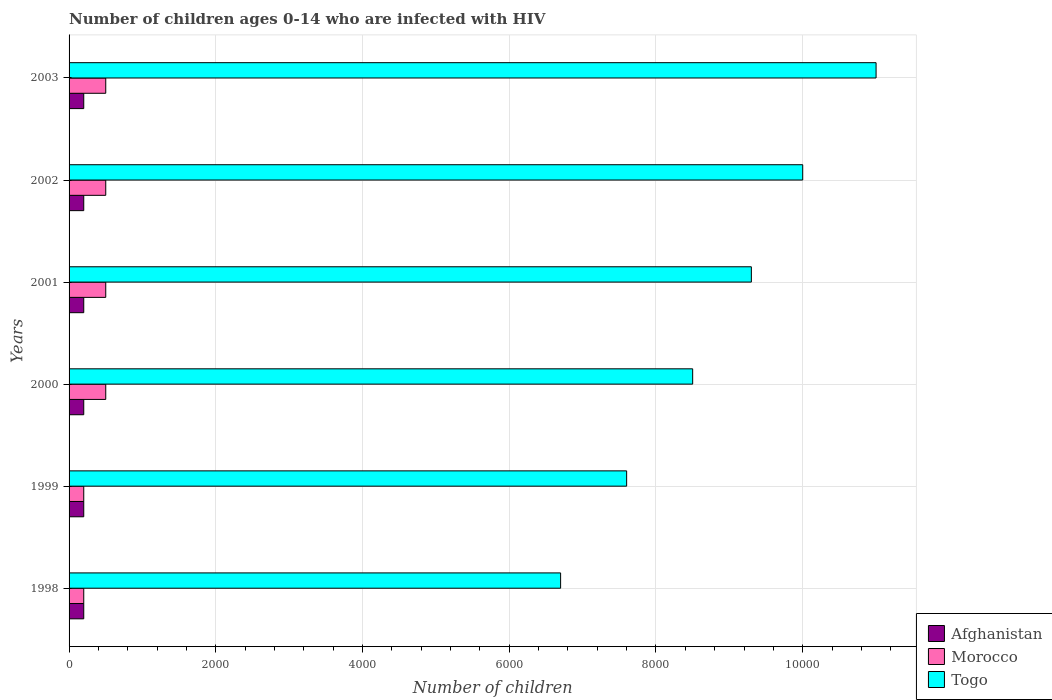How many different coloured bars are there?
Ensure brevity in your answer.  3. How many groups of bars are there?
Keep it short and to the point. 6. Are the number of bars per tick equal to the number of legend labels?
Offer a terse response. Yes. Are the number of bars on each tick of the Y-axis equal?
Give a very brief answer. Yes. How many bars are there on the 6th tick from the top?
Make the answer very short. 3. How many bars are there on the 3rd tick from the bottom?
Keep it short and to the point. 3. What is the number of HIV infected children in Morocco in 2001?
Offer a very short reply. 500. Across all years, what is the maximum number of HIV infected children in Morocco?
Your answer should be very brief. 500. Across all years, what is the minimum number of HIV infected children in Morocco?
Keep it short and to the point. 200. In which year was the number of HIV infected children in Morocco maximum?
Ensure brevity in your answer.  2000. What is the total number of HIV infected children in Morocco in the graph?
Offer a very short reply. 2400. What is the difference between the number of HIV infected children in Afghanistan in 2001 and the number of HIV infected children in Togo in 2003?
Make the answer very short. -1.08e+04. In the year 2003, what is the difference between the number of HIV infected children in Togo and number of HIV infected children in Morocco?
Your answer should be compact. 1.05e+04. In how many years, is the number of HIV infected children in Togo greater than 5200 ?
Provide a short and direct response. 6. What is the ratio of the number of HIV infected children in Togo in 1999 to that in 2002?
Ensure brevity in your answer.  0.76. What is the difference between the highest and the lowest number of HIV infected children in Togo?
Keep it short and to the point. 4300. What does the 3rd bar from the top in 1998 represents?
Ensure brevity in your answer.  Afghanistan. What does the 1st bar from the bottom in 2003 represents?
Keep it short and to the point. Afghanistan. Is it the case that in every year, the sum of the number of HIV infected children in Togo and number of HIV infected children in Morocco is greater than the number of HIV infected children in Afghanistan?
Your response must be concise. Yes. Are all the bars in the graph horizontal?
Your answer should be compact. Yes. How many years are there in the graph?
Your response must be concise. 6. What is the difference between two consecutive major ticks on the X-axis?
Ensure brevity in your answer.  2000. Are the values on the major ticks of X-axis written in scientific E-notation?
Your answer should be compact. No. Does the graph contain any zero values?
Offer a very short reply. No. Does the graph contain grids?
Keep it short and to the point. Yes. Where does the legend appear in the graph?
Keep it short and to the point. Bottom right. How many legend labels are there?
Give a very brief answer. 3. What is the title of the graph?
Your answer should be compact. Number of children ages 0-14 who are infected with HIV. What is the label or title of the X-axis?
Your answer should be compact. Number of children. What is the label or title of the Y-axis?
Your answer should be compact. Years. What is the Number of children in Togo in 1998?
Make the answer very short. 6700. What is the Number of children in Morocco in 1999?
Make the answer very short. 200. What is the Number of children of Togo in 1999?
Your answer should be very brief. 7600. What is the Number of children in Afghanistan in 2000?
Your answer should be very brief. 200. What is the Number of children in Morocco in 2000?
Make the answer very short. 500. What is the Number of children in Togo in 2000?
Provide a short and direct response. 8500. What is the Number of children in Morocco in 2001?
Make the answer very short. 500. What is the Number of children of Togo in 2001?
Provide a succinct answer. 9300. What is the Number of children in Morocco in 2002?
Offer a terse response. 500. What is the Number of children in Togo in 2002?
Your answer should be very brief. 10000. What is the Number of children in Morocco in 2003?
Your answer should be compact. 500. What is the Number of children of Togo in 2003?
Offer a very short reply. 1.10e+04. Across all years, what is the maximum Number of children of Morocco?
Your response must be concise. 500. Across all years, what is the maximum Number of children in Togo?
Provide a succinct answer. 1.10e+04. Across all years, what is the minimum Number of children in Afghanistan?
Give a very brief answer. 200. Across all years, what is the minimum Number of children in Morocco?
Provide a succinct answer. 200. Across all years, what is the minimum Number of children of Togo?
Your answer should be very brief. 6700. What is the total Number of children in Afghanistan in the graph?
Provide a short and direct response. 1200. What is the total Number of children in Morocco in the graph?
Keep it short and to the point. 2400. What is the total Number of children in Togo in the graph?
Your answer should be compact. 5.31e+04. What is the difference between the Number of children of Togo in 1998 and that in 1999?
Keep it short and to the point. -900. What is the difference between the Number of children in Morocco in 1998 and that in 2000?
Your answer should be very brief. -300. What is the difference between the Number of children in Togo in 1998 and that in 2000?
Your answer should be very brief. -1800. What is the difference between the Number of children in Afghanistan in 1998 and that in 2001?
Provide a succinct answer. 0. What is the difference between the Number of children in Morocco in 1998 and that in 2001?
Keep it short and to the point. -300. What is the difference between the Number of children in Togo in 1998 and that in 2001?
Make the answer very short. -2600. What is the difference between the Number of children in Afghanistan in 1998 and that in 2002?
Provide a short and direct response. 0. What is the difference between the Number of children of Morocco in 1998 and that in 2002?
Offer a terse response. -300. What is the difference between the Number of children in Togo in 1998 and that in 2002?
Offer a terse response. -3300. What is the difference between the Number of children of Morocco in 1998 and that in 2003?
Make the answer very short. -300. What is the difference between the Number of children in Togo in 1998 and that in 2003?
Provide a succinct answer. -4300. What is the difference between the Number of children in Afghanistan in 1999 and that in 2000?
Your answer should be compact. 0. What is the difference between the Number of children in Morocco in 1999 and that in 2000?
Your response must be concise. -300. What is the difference between the Number of children in Togo in 1999 and that in 2000?
Offer a terse response. -900. What is the difference between the Number of children in Morocco in 1999 and that in 2001?
Your response must be concise. -300. What is the difference between the Number of children in Togo in 1999 and that in 2001?
Your answer should be very brief. -1700. What is the difference between the Number of children of Afghanistan in 1999 and that in 2002?
Offer a very short reply. 0. What is the difference between the Number of children of Morocco in 1999 and that in 2002?
Ensure brevity in your answer.  -300. What is the difference between the Number of children in Togo in 1999 and that in 2002?
Your answer should be very brief. -2400. What is the difference between the Number of children in Afghanistan in 1999 and that in 2003?
Your answer should be compact. 0. What is the difference between the Number of children in Morocco in 1999 and that in 2003?
Keep it short and to the point. -300. What is the difference between the Number of children of Togo in 1999 and that in 2003?
Provide a succinct answer. -3400. What is the difference between the Number of children of Afghanistan in 2000 and that in 2001?
Your answer should be compact. 0. What is the difference between the Number of children of Morocco in 2000 and that in 2001?
Keep it short and to the point. 0. What is the difference between the Number of children in Togo in 2000 and that in 2001?
Give a very brief answer. -800. What is the difference between the Number of children in Afghanistan in 2000 and that in 2002?
Offer a terse response. 0. What is the difference between the Number of children in Morocco in 2000 and that in 2002?
Your answer should be compact. 0. What is the difference between the Number of children in Togo in 2000 and that in 2002?
Offer a terse response. -1500. What is the difference between the Number of children of Afghanistan in 2000 and that in 2003?
Your response must be concise. 0. What is the difference between the Number of children in Morocco in 2000 and that in 2003?
Provide a succinct answer. 0. What is the difference between the Number of children of Togo in 2000 and that in 2003?
Give a very brief answer. -2500. What is the difference between the Number of children of Morocco in 2001 and that in 2002?
Provide a succinct answer. 0. What is the difference between the Number of children in Togo in 2001 and that in 2002?
Provide a short and direct response. -700. What is the difference between the Number of children in Afghanistan in 2001 and that in 2003?
Your answer should be compact. 0. What is the difference between the Number of children of Togo in 2001 and that in 2003?
Your answer should be compact. -1700. What is the difference between the Number of children in Togo in 2002 and that in 2003?
Provide a succinct answer. -1000. What is the difference between the Number of children in Afghanistan in 1998 and the Number of children in Togo in 1999?
Give a very brief answer. -7400. What is the difference between the Number of children of Morocco in 1998 and the Number of children of Togo in 1999?
Give a very brief answer. -7400. What is the difference between the Number of children of Afghanistan in 1998 and the Number of children of Morocco in 2000?
Keep it short and to the point. -300. What is the difference between the Number of children of Afghanistan in 1998 and the Number of children of Togo in 2000?
Provide a short and direct response. -8300. What is the difference between the Number of children of Morocco in 1998 and the Number of children of Togo in 2000?
Your answer should be very brief. -8300. What is the difference between the Number of children in Afghanistan in 1998 and the Number of children in Morocco in 2001?
Give a very brief answer. -300. What is the difference between the Number of children in Afghanistan in 1998 and the Number of children in Togo in 2001?
Ensure brevity in your answer.  -9100. What is the difference between the Number of children of Morocco in 1998 and the Number of children of Togo in 2001?
Offer a very short reply. -9100. What is the difference between the Number of children of Afghanistan in 1998 and the Number of children of Morocco in 2002?
Make the answer very short. -300. What is the difference between the Number of children of Afghanistan in 1998 and the Number of children of Togo in 2002?
Provide a succinct answer. -9800. What is the difference between the Number of children of Morocco in 1998 and the Number of children of Togo in 2002?
Offer a terse response. -9800. What is the difference between the Number of children in Afghanistan in 1998 and the Number of children in Morocco in 2003?
Keep it short and to the point. -300. What is the difference between the Number of children in Afghanistan in 1998 and the Number of children in Togo in 2003?
Provide a short and direct response. -1.08e+04. What is the difference between the Number of children of Morocco in 1998 and the Number of children of Togo in 2003?
Make the answer very short. -1.08e+04. What is the difference between the Number of children of Afghanistan in 1999 and the Number of children of Morocco in 2000?
Offer a terse response. -300. What is the difference between the Number of children in Afghanistan in 1999 and the Number of children in Togo in 2000?
Provide a short and direct response. -8300. What is the difference between the Number of children in Morocco in 1999 and the Number of children in Togo in 2000?
Give a very brief answer. -8300. What is the difference between the Number of children in Afghanistan in 1999 and the Number of children in Morocco in 2001?
Keep it short and to the point. -300. What is the difference between the Number of children in Afghanistan in 1999 and the Number of children in Togo in 2001?
Give a very brief answer. -9100. What is the difference between the Number of children of Morocco in 1999 and the Number of children of Togo in 2001?
Keep it short and to the point. -9100. What is the difference between the Number of children of Afghanistan in 1999 and the Number of children of Morocco in 2002?
Your answer should be compact. -300. What is the difference between the Number of children in Afghanistan in 1999 and the Number of children in Togo in 2002?
Offer a terse response. -9800. What is the difference between the Number of children of Morocco in 1999 and the Number of children of Togo in 2002?
Your answer should be very brief. -9800. What is the difference between the Number of children of Afghanistan in 1999 and the Number of children of Morocco in 2003?
Your answer should be very brief. -300. What is the difference between the Number of children of Afghanistan in 1999 and the Number of children of Togo in 2003?
Your answer should be very brief. -1.08e+04. What is the difference between the Number of children in Morocco in 1999 and the Number of children in Togo in 2003?
Offer a very short reply. -1.08e+04. What is the difference between the Number of children in Afghanistan in 2000 and the Number of children in Morocco in 2001?
Your response must be concise. -300. What is the difference between the Number of children of Afghanistan in 2000 and the Number of children of Togo in 2001?
Your answer should be compact. -9100. What is the difference between the Number of children of Morocco in 2000 and the Number of children of Togo in 2001?
Offer a very short reply. -8800. What is the difference between the Number of children in Afghanistan in 2000 and the Number of children in Morocco in 2002?
Your answer should be very brief. -300. What is the difference between the Number of children of Afghanistan in 2000 and the Number of children of Togo in 2002?
Your answer should be compact. -9800. What is the difference between the Number of children in Morocco in 2000 and the Number of children in Togo in 2002?
Offer a very short reply. -9500. What is the difference between the Number of children of Afghanistan in 2000 and the Number of children of Morocco in 2003?
Keep it short and to the point. -300. What is the difference between the Number of children in Afghanistan in 2000 and the Number of children in Togo in 2003?
Offer a terse response. -1.08e+04. What is the difference between the Number of children of Morocco in 2000 and the Number of children of Togo in 2003?
Provide a short and direct response. -1.05e+04. What is the difference between the Number of children in Afghanistan in 2001 and the Number of children in Morocco in 2002?
Ensure brevity in your answer.  -300. What is the difference between the Number of children of Afghanistan in 2001 and the Number of children of Togo in 2002?
Ensure brevity in your answer.  -9800. What is the difference between the Number of children of Morocco in 2001 and the Number of children of Togo in 2002?
Offer a terse response. -9500. What is the difference between the Number of children of Afghanistan in 2001 and the Number of children of Morocco in 2003?
Give a very brief answer. -300. What is the difference between the Number of children of Afghanistan in 2001 and the Number of children of Togo in 2003?
Your answer should be very brief. -1.08e+04. What is the difference between the Number of children in Morocco in 2001 and the Number of children in Togo in 2003?
Your answer should be compact. -1.05e+04. What is the difference between the Number of children in Afghanistan in 2002 and the Number of children in Morocco in 2003?
Give a very brief answer. -300. What is the difference between the Number of children in Afghanistan in 2002 and the Number of children in Togo in 2003?
Your answer should be compact. -1.08e+04. What is the difference between the Number of children in Morocco in 2002 and the Number of children in Togo in 2003?
Provide a succinct answer. -1.05e+04. What is the average Number of children in Afghanistan per year?
Give a very brief answer. 200. What is the average Number of children of Togo per year?
Give a very brief answer. 8850. In the year 1998, what is the difference between the Number of children in Afghanistan and Number of children in Morocco?
Your response must be concise. 0. In the year 1998, what is the difference between the Number of children of Afghanistan and Number of children of Togo?
Keep it short and to the point. -6500. In the year 1998, what is the difference between the Number of children in Morocco and Number of children in Togo?
Your answer should be compact. -6500. In the year 1999, what is the difference between the Number of children in Afghanistan and Number of children in Togo?
Your answer should be compact. -7400. In the year 1999, what is the difference between the Number of children of Morocco and Number of children of Togo?
Give a very brief answer. -7400. In the year 2000, what is the difference between the Number of children in Afghanistan and Number of children in Morocco?
Provide a succinct answer. -300. In the year 2000, what is the difference between the Number of children of Afghanistan and Number of children of Togo?
Make the answer very short. -8300. In the year 2000, what is the difference between the Number of children of Morocco and Number of children of Togo?
Give a very brief answer. -8000. In the year 2001, what is the difference between the Number of children of Afghanistan and Number of children of Morocco?
Provide a succinct answer. -300. In the year 2001, what is the difference between the Number of children in Afghanistan and Number of children in Togo?
Ensure brevity in your answer.  -9100. In the year 2001, what is the difference between the Number of children of Morocco and Number of children of Togo?
Your answer should be very brief. -8800. In the year 2002, what is the difference between the Number of children in Afghanistan and Number of children in Morocco?
Offer a terse response. -300. In the year 2002, what is the difference between the Number of children of Afghanistan and Number of children of Togo?
Keep it short and to the point. -9800. In the year 2002, what is the difference between the Number of children of Morocco and Number of children of Togo?
Your answer should be compact. -9500. In the year 2003, what is the difference between the Number of children in Afghanistan and Number of children in Morocco?
Keep it short and to the point. -300. In the year 2003, what is the difference between the Number of children in Afghanistan and Number of children in Togo?
Keep it short and to the point. -1.08e+04. In the year 2003, what is the difference between the Number of children of Morocco and Number of children of Togo?
Your answer should be very brief. -1.05e+04. What is the ratio of the Number of children in Morocco in 1998 to that in 1999?
Provide a succinct answer. 1. What is the ratio of the Number of children in Togo in 1998 to that in 1999?
Provide a short and direct response. 0.88. What is the ratio of the Number of children in Togo in 1998 to that in 2000?
Keep it short and to the point. 0.79. What is the ratio of the Number of children in Afghanistan in 1998 to that in 2001?
Keep it short and to the point. 1. What is the ratio of the Number of children in Morocco in 1998 to that in 2001?
Give a very brief answer. 0.4. What is the ratio of the Number of children in Togo in 1998 to that in 2001?
Offer a terse response. 0.72. What is the ratio of the Number of children of Morocco in 1998 to that in 2002?
Offer a very short reply. 0.4. What is the ratio of the Number of children of Togo in 1998 to that in 2002?
Your response must be concise. 0.67. What is the ratio of the Number of children in Afghanistan in 1998 to that in 2003?
Offer a very short reply. 1. What is the ratio of the Number of children of Togo in 1998 to that in 2003?
Your response must be concise. 0.61. What is the ratio of the Number of children in Togo in 1999 to that in 2000?
Offer a very short reply. 0.89. What is the ratio of the Number of children in Afghanistan in 1999 to that in 2001?
Your answer should be compact. 1. What is the ratio of the Number of children of Togo in 1999 to that in 2001?
Your answer should be compact. 0.82. What is the ratio of the Number of children in Morocco in 1999 to that in 2002?
Provide a short and direct response. 0.4. What is the ratio of the Number of children in Togo in 1999 to that in 2002?
Your answer should be very brief. 0.76. What is the ratio of the Number of children of Afghanistan in 1999 to that in 2003?
Provide a short and direct response. 1. What is the ratio of the Number of children of Togo in 1999 to that in 2003?
Provide a short and direct response. 0.69. What is the ratio of the Number of children of Morocco in 2000 to that in 2001?
Your response must be concise. 1. What is the ratio of the Number of children in Togo in 2000 to that in 2001?
Offer a very short reply. 0.91. What is the ratio of the Number of children of Togo in 2000 to that in 2002?
Your answer should be compact. 0.85. What is the ratio of the Number of children in Morocco in 2000 to that in 2003?
Offer a terse response. 1. What is the ratio of the Number of children of Togo in 2000 to that in 2003?
Your response must be concise. 0.77. What is the ratio of the Number of children of Togo in 2001 to that in 2002?
Offer a very short reply. 0.93. What is the ratio of the Number of children in Afghanistan in 2001 to that in 2003?
Offer a very short reply. 1. What is the ratio of the Number of children of Togo in 2001 to that in 2003?
Provide a succinct answer. 0.85. What is the ratio of the Number of children of Morocco in 2002 to that in 2003?
Your answer should be very brief. 1. What is the ratio of the Number of children in Togo in 2002 to that in 2003?
Offer a terse response. 0.91. What is the difference between the highest and the second highest Number of children in Morocco?
Keep it short and to the point. 0. What is the difference between the highest and the second highest Number of children of Togo?
Offer a very short reply. 1000. What is the difference between the highest and the lowest Number of children of Morocco?
Offer a very short reply. 300. What is the difference between the highest and the lowest Number of children in Togo?
Give a very brief answer. 4300. 